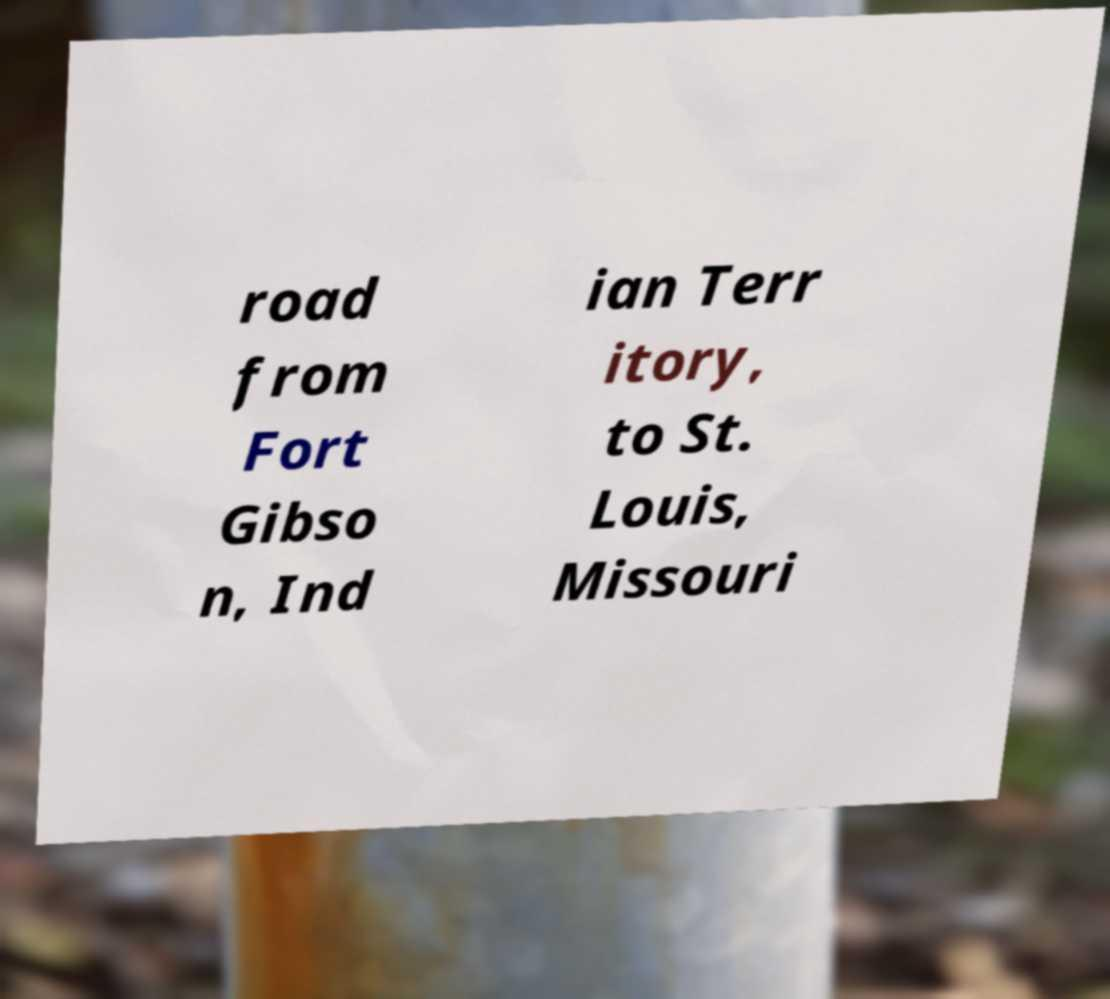Could you extract and type out the text from this image? road from Fort Gibso n, Ind ian Terr itory, to St. Louis, Missouri 